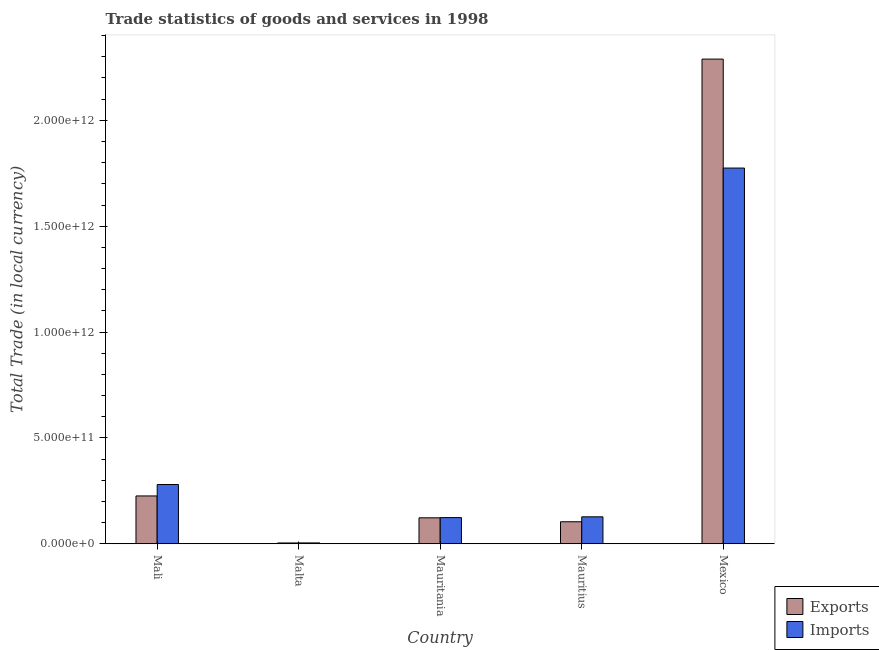How many different coloured bars are there?
Provide a short and direct response. 2. Are the number of bars per tick equal to the number of legend labels?
Provide a succinct answer. Yes. Are the number of bars on each tick of the X-axis equal?
Ensure brevity in your answer.  Yes. What is the label of the 3rd group of bars from the left?
Provide a short and direct response. Mauritania. What is the export of goods and services in Malta?
Provide a succinct answer. 3.67e+09. Across all countries, what is the maximum export of goods and services?
Offer a very short reply. 2.29e+12. Across all countries, what is the minimum imports of goods and services?
Your answer should be very brief. 3.91e+09. In which country was the export of goods and services maximum?
Ensure brevity in your answer.  Mexico. In which country was the imports of goods and services minimum?
Provide a short and direct response. Malta. What is the total export of goods and services in the graph?
Keep it short and to the point. 2.75e+12. What is the difference between the export of goods and services in Mali and that in Mauritania?
Give a very brief answer. 1.03e+11. What is the difference between the export of goods and services in Mexico and the imports of goods and services in Malta?
Ensure brevity in your answer.  2.29e+12. What is the average imports of goods and services per country?
Your answer should be compact. 4.62e+11. What is the difference between the imports of goods and services and export of goods and services in Mauritania?
Provide a succinct answer. 1.12e+09. What is the ratio of the export of goods and services in Mauritania to that in Mauritius?
Give a very brief answer. 1.18. Is the difference between the imports of goods and services in Mali and Mauritius greater than the difference between the export of goods and services in Mali and Mauritius?
Offer a very short reply. Yes. What is the difference between the highest and the second highest imports of goods and services?
Keep it short and to the point. 1.49e+12. What is the difference between the highest and the lowest export of goods and services?
Offer a terse response. 2.29e+12. What does the 2nd bar from the left in Mali represents?
Provide a succinct answer. Imports. What does the 2nd bar from the right in Mexico represents?
Your answer should be compact. Exports. How many bars are there?
Give a very brief answer. 10. Are all the bars in the graph horizontal?
Give a very brief answer. No. What is the difference between two consecutive major ticks on the Y-axis?
Offer a very short reply. 5.00e+11. Does the graph contain any zero values?
Give a very brief answer. No. How many legend labels are there?
Your answer should be compact. 2. How are the legend labels stacked?
Offer a terse response. Vertical. What is the title of the graph?
Provide a succinct answer. Trade statistics of goods and services in 1998. Does "Primary completion rate" appear as one of the legend labels in the graph?
Give a very brief answer. No. What is the label or title of the X-axis?
Your answer should be compact. Country. What is the label or title of the Y-axis?
Make the answer very short. Total Trade (in local currency). What is the Total Trade (in local currency) in Exports in Mali?
Make the answer very short. 2.26e+11. What is the Total Trade (in local currency) of Imports in Mali?
Give a very brief answer. 2.80e+11. What is the Total Trade (in local currency) of Exports in Malta?
Provide a succinct answer. 3.67e+09. What is the Total Trade (in local currency) in Imports in Malta?
Ensure brevity in your answer.  3.91e+09. What is the Total Trade (in local currency) of Exports in Mauritania?
Ensure brevity in your answer.  1.22e+11. What is the Total Trade (in local currency) in Imports in Mauritania?
Provide a short and direct response. 1.24e+11. What is the Total Trade (in local currency) in Exports in Mauritius?
Provide a short and direct response. 1.04e+11. What is the Total Trade (in local currency) of Imports in Mauritius?
Provide a succinct answer. 1.27e+11. What is the Total Trade (in local currency) of Exports in Mexico?
Keep it short and to the point. 2.29e+12. What is the Total Trade (in local currency) of Imports in Mexico?
Keep it short and to the point. 1.77e+12. Across all countries, what is the maximum Total Trade (in local currency) of Exports?
Give a very brief answer. 2.29e+12. Across all countries, what is the maximum Total Trade (in local currency) of Imports?
Your answer should be compact. 1.77e+12. Across all countries, what is the minimum Total Trade (in local currency) of Exports?
Keep it short and to the point. 3.67e+09. Across all countries, what is the minimum Total Trade (in local currency) of Imports?
Your response must be concise. 3.91e+09. What is the total Total Trade (in local currency) of Exports in the graph?
Your response must be concise. 2.75e+12. What is the total Total Trade (in local currency) in Imports in the graph?
Give a very brief answer. 2.31e+12. What is the difference between the Total Trade (in local currency) in Exports in Mali and that in Malta?
Your response must be concise. 2.22e+11. What is the difference between the Total Trade (in local currency) of Imports in Mali and that in Malta?
Your answer should be compact. 2.76e+11. What is the difference between the Total Trade (in local currency) of Exports in Mali and that in Mauritania?
Your answer should be compact. 1.03e+11. What is the difference between the Total Trade (in local currency) in Imports in Mali and that in Mauritania?
Give a very brief answer. 1.56e+11. What is the difference between the Total Trade (in local currency) of Exports in Mali and that in Mauritius?
Keep it short and to the point. 1.22e+11. What is the difference between the Total Trade (in local currency) of Imports in Mali and that in Mauritius?
Offer a very short reply. 1.53e+11. What is the difference between the Total Trade (in local currency) of Exports in Mali and that in Mexico?
Provide a succinct answer. -2.06e+12. What is the difference between the Total Trade (in local currency) in Imports in Mali and that in Mexico?
Your response must be concise. -1.49e+12. What is the difference between the Total Trade (in local currency) of Exports in Malta and that in Mauritania?
Your answer should be very brief. -1.19e+11. What is the difference between the Total Trade (in local currency) in Imports in Malta and that in Mauritania?
Keep it short and to the point. -1.20e+11. What is the difference between the Total Trade (in local currency) in Exports in Malta and that in Mauritius?
Offer a very short reply. -1.00e+11. What is the difference between the Total Trade (in local currency) in Imports in Malta and that in Mauritius?
Keep it short and to the point. -1.23e+11. What is the difference between the Total Trade (in local currency) in Exports in Malta and that in Mexico?
Provide a succinct answer. -2.29e+12. What is the difference between the Total Trade (in local currency) of Imports in Malta and that in Mexico?
Provide a succinct answer. -1.77e+12. What is the difference between the Total Trade (in local currency) in Exports in Mauritania and that in Mauritius?
Keep it short and to the point. 1.86e+1. What is the difference between the Total Trade (in local currency) of Imports in Mauritania and that in Mauritius?
Make the answer very short. -3.60e+09. What is the difference between the Total Trade (in local currency) in Exports in Mauritania and that in Mexico?
Provide a succinct answer. -2.17e+12. What is the difference between the Total Trade (in local currency) of Imports in Mauritania and that in Mexico?
Ensure brevity in your answer.  -1.65e+12. What is the difference between the Total Trade (in local currency) in Exports in Mauritius and that in Mexico?
Ensure brevity in your answer.  -2.19e+12. What is the difference between the Total Trade (in local currency) of Imports in Mauritius and that in Mexico?
Your answer should be compact. -1.65e+12. What is the difference between the Total Trade (in local currency) of Exports in Mali and the Total Trade (in local currency) of Imports in Malta?
Give a very brief answer. 2.22e+11. What is the difference between the Total Trade (in local currency) in Exports in Mali and the Total Trade (in local currency) in Imports in Mauritania?
Provide a short and direct response. 1.02e+11. What is the difference between the Total Trade (in local currency) of Exports in Mali and the Total Trade (in local currency) of Imports in Mauritius?
Keep it short and to the point. 9.86e+1. What is the difference between the Total Trade (in local currency) in Exports in Mali and the Total Trade (in local currency) in Imports in Mexico?
Give a very brief answer. -1.55e+12. What is the difference between the Total Trade (in local currency) in Exports in Malta and the Total Trade (in local currency) in Imports in Mauritania?
Your response must be concise. -1.20e+11. What is the difference between the Total Trade (in local currency) in Exports in Malta and the Total Trade (in local currency) in Imports in Mauritius?
Provide a short and direct response. -1.24e+11. What is the difference between the Total Trade (in local currency) in Exports in Malta and the Total Trade (in local currency) in Imports in Mexico?
Provide a short and direct response. -1.77e+12. What is the difference between the Total Trade (in local currency) in Exports in Mauritania and the Total Trade (in local currency) in Imports in Mauritius?
Provide a succinct answer. -4.72e+09. What is the difference between the Total Trade (in local currency) in Exports in Mauritania and the Total Trade (in local currency) in Imports in Mexico?
Provide a succinct answer. -1.65e+12. What is the difference between the Total Trade (in local currency) in Exports in Mauritius and the Total Trade (in local currency) in Imports in Mexico?
Provide a short and direct response. -1.67e+12. What is the average Total Trade (in local currency) of Exports per country?
Give a very brief answer. 5.49e+11. What is the average Total Trade (in local currency) in Imports per country?
Offer a terse response. 4.62e+11. What is the difference between the Total Trade (in local currency) of Exports and Total Trade (in local currency) of Imports in Mali?
Keep it short and to the point. -5.40e+1. What is the difference between the Total Trade (in local currency) of Exports and Total Trade (in local currency) of Imports in Malta?
Your response must be concise. -2.40e+08. What is the difference between the Total Trade (in local currency) in Exports and Total Trade (in local currency) in Imports in Mauritania?
Provide a succinct answer. -1.12e+09. What is the difference between the Total Trade (in local currency) in Exports and Total Trade (in local currency) in Imports in Mauritius?
Make the answer very short. -2.33e+1. What is the difference between the Total Trade (in local currency) in Exports and Total Trade (in local currency) in Imports in Mexico?
Offer a very short reply. 5.15e+11. What is the ratio of the Total Trade (in local currency) of Exports in Mali to that in Malta?
Your answer should be very brief. 61.5. What is the ratio of the Total Trade (in local currency) in Imports in Mali to that in Malta?
Your answer should be very brief. 71.54. What is the ratio of the Total Trade (in local currency) of Exports in Mali to that in Mauritania?
Offer a very short reply. 1.84. What is the ratio of the Total Trade (in local currency) of Imports in Mali to that in Mauritania?
Ensure brevity in your answer.  2.26. What is the ratio of the Total Trade (in local currency) in Exports in Mali to that in Mauritius?
Your response must be concise. 2.17. What is the ratio of the Total Trade (in local currency) in Imports in Mali to that in Mauritius?
Your response must be concise. 2.2. What is the ratio of the Total Trade (in local currency) of Exports in Mali to that in Mexico?
Keep it short and to the point. 0.1. What is the ratio of the Total Trade (in local currency) in Imports in Mali to that in Mexico?
Your answer should be compact. 0.16. What is the ratio of the Total Trade (in local currency) of Imports in Malta to that in Mauritania?
Make the answer very short. 0.03. What is the ratio of the Total Trade (in local currency) in Exports in Malta to that in Mauritius?
Keep it short and to the point. 0.04. What is the ratio of the Total Trade (in local currency) of Imports in Malta to that in Mauritius?
Give a very brief answer. 0.03. What is the ratio of the Total Trade (in local currency) of Exports in Malta to that in Mexico?
Offer a very short reply. 0. What is the ratio of the Total Trade (in local currency) of Imports in Malta to that in Mexico?
Offer a terse response. 0. What is the ratio of the Total Trade (in local currency) in Exports in Mauritania to that in Mauritius?
Ensure brevity in your answer.  1.18. What is the ratio of the Total Trade (in local currency) in Imports in Mauritania to that in Mauritius?
Provide a succinct answer. 0.97. What is the ratio of the Total Trade (in local currency) in Exports in Mauritania to that in Mexico?
Keep it short and to the point. 0.05. What is the ratio of the Total Trade (in local currency) of Imports in Mauritania to that in Mexico?
Your answer should be very brief. 0.07. What is the ratio of the Total Trade (in local currency) in Exports in Mauritius to that in Mexico?
Provide a short and direct response. 0.05. What is the ratio of the Total Trade (in local currency) of Imports in Mauritius to that in Mexico?
Your response must be concise. 0.07. What is the difference between the highest and the second highest Total Trade (in local currency) in Exports?
Offer a terse response. 2.06e+12. What is the difference between the highest and the second highest Total Trade (in local currency) of Imports?
Provide a short and direct response. 1.49e+12. What is the difference between the highest and the lowest Total Trade (in local currency) of Exports?
Provide a succinct answer. 2.29e+12. What is the difference between the highest and the lowest Total Trade (in local currency) in Imports?
Your response must be concise. 1.77e+12. 